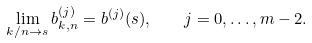<formula> <loc_0><loc_0><loc_500><loc_500>\lim _ { k / n \to s } b ^ { ( j ) } _ { k , n } = b ^ { ( j ) } ( s ) , \quad j = 0 , \dots , m - 2 .</formula> 